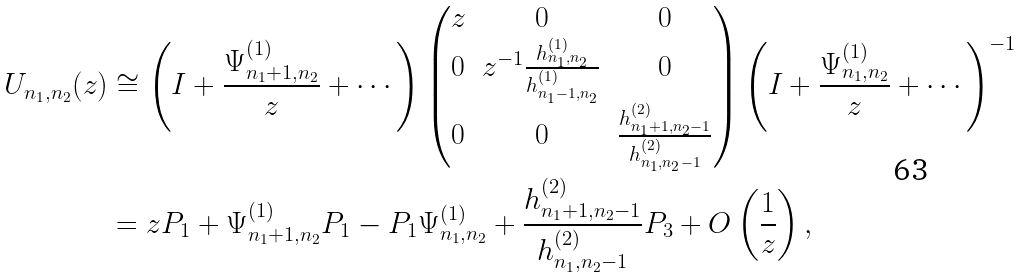<formula> <loc_0><loc_0><loc_500><loc_500>U _ { n _ { 1 } , n _ { 2 } } ( z ) & \cong \left ( I + \frac { \Psi ^ { ( 1 ) } _ { n _ { 1 } + 1 , n _ { 2 } } } { z } + \cdots \right ) \begin{pmatrix} z & 0 & 0 \\ 0 & z ^ { - 1 } \frac { h ^ { ( 1 ) } _ { n _ { 1 } , n _ { 2 } } } { h ^ { ( 1 ) } _ { n _ { 1 } - 1 , n _ { 2 } } } & 0 \\ 0 & 0 & \frac { h ^ { ( 2 ) } _ { n _ { 1 } + 1 , n _ { 2 } - 1 } } { h ^ { ( 2 ) } _ { n _ { 1 } , n _ { 2 } - 1 } } \end{pmatrix} \left ( I + \frac { \Psi ^ { ( 1 ) } _ { n _ { 1 } , n _ { 2 } } } { z } + \cdots \right ) ^ { - 1 } \\ & = z P _ { 1 } + \Psi ^ { ( 1 ) } _ { n _ { 1 } + 1 , n _ { 2 } } P _ { 1 } - P _ { 1 } \Psi ^ { ( 1 ) } _ { n _ { 1 } , n _ { 2 } } + \frac { h ^ { ( 2 ) } _ { n _ { 1 } + 1 , n _ { 2 } - 1 } } { h ^ { ( 2 ) } _ { n _ { 1 } , n _ { 2 } - 1 } } P _ { 3 } + O \left ( \frac { 1 } { z } \right ) ,</formula> 